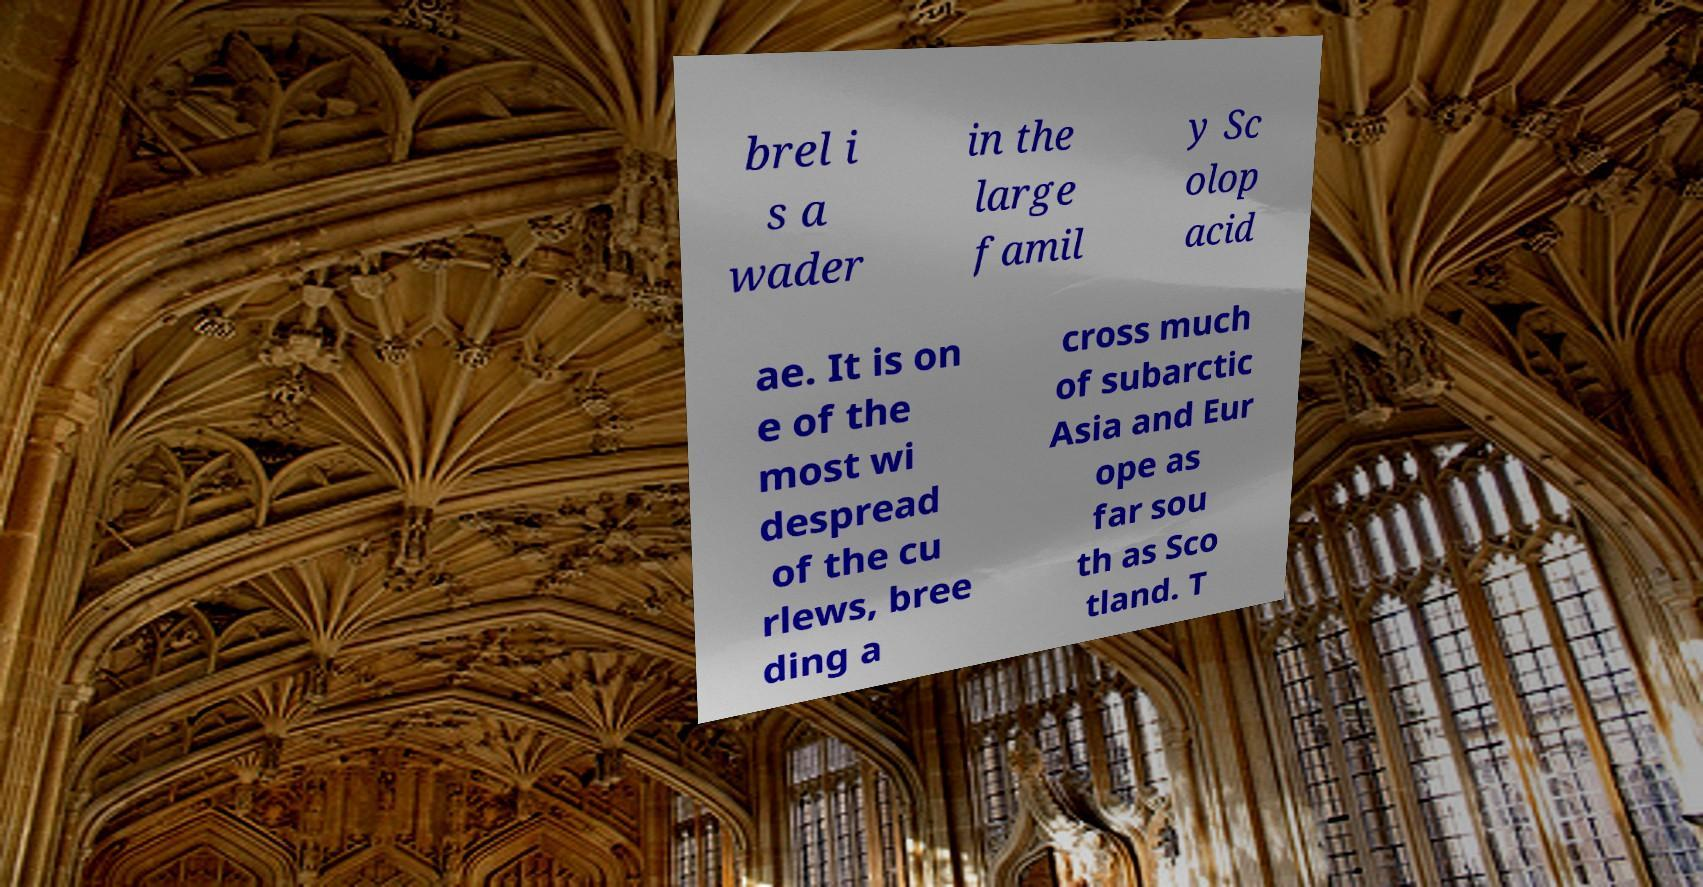What messages or text are displayed in this image? I need them in a readable, typed format. brel i s a wader in the large famil y Sc olop acid ae. It is on e of the most wi despread of the cu rlews, bree ding a cross much of subarctic Asia and Eur ope as far sou th as Sco tland. T 